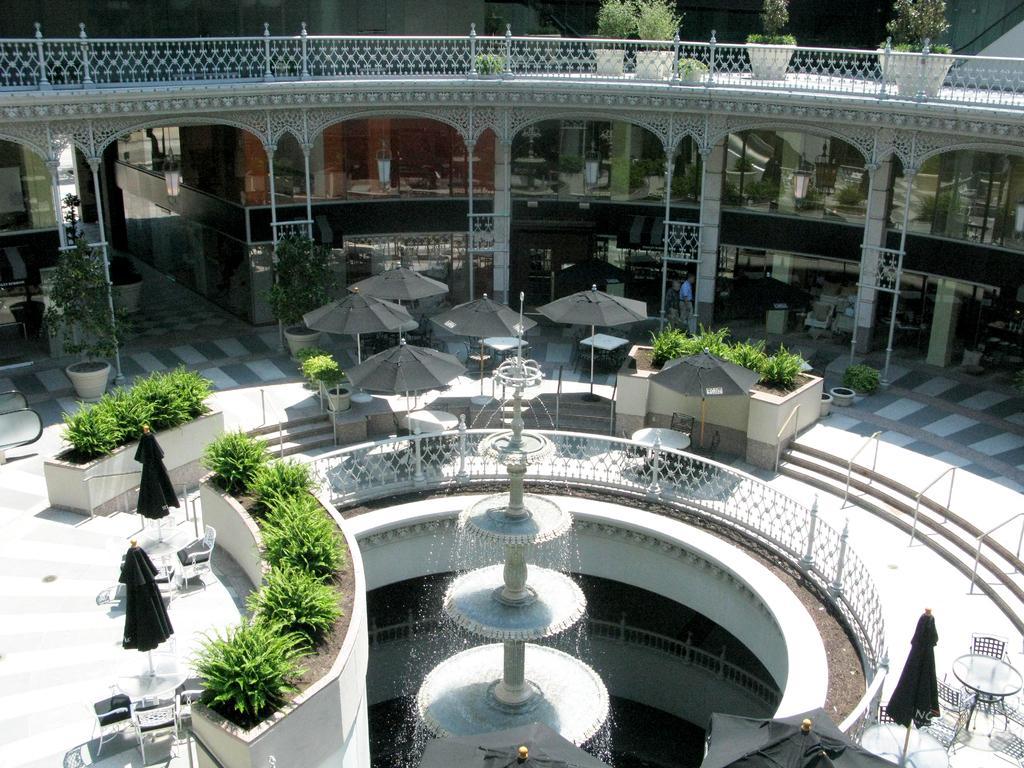Could you give a brief overview of what you see in this image? In this image we can see the fountain in the middle of the image and there are some chairs and tables and we can see some umbrellas. We can see some plants and there are some potted plants and we can see a building in the background and there are two persons walking in front of the building. 